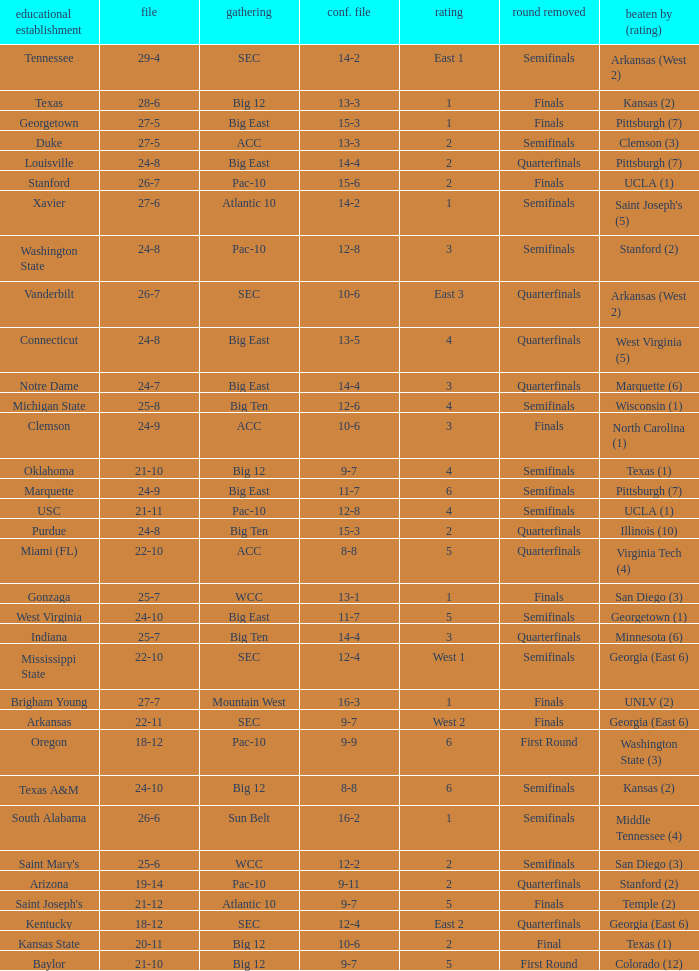Name the conference record where seed is 3 and record is 24-9 10-6. 